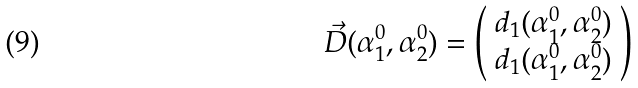<formula> <loc_0><loc_0><loc_500><loc_500>\vec { D } ( \alpha _ { 1 } ^ { 0 } , \alpha _ { 2 } ^ { 0 } ) = \left ( \begin{array} { l } d _ { 1 } ( \alpha _ { 1 } ^ { 0 } , \alpha _ { 2 } ^ { 0 } ) \\ d _ { 1 } ( \alpha _ { 1 } ^ { 0 } , \alpha _ { 2 } ^ { 0 } ) \end{array} \right )</formula> 